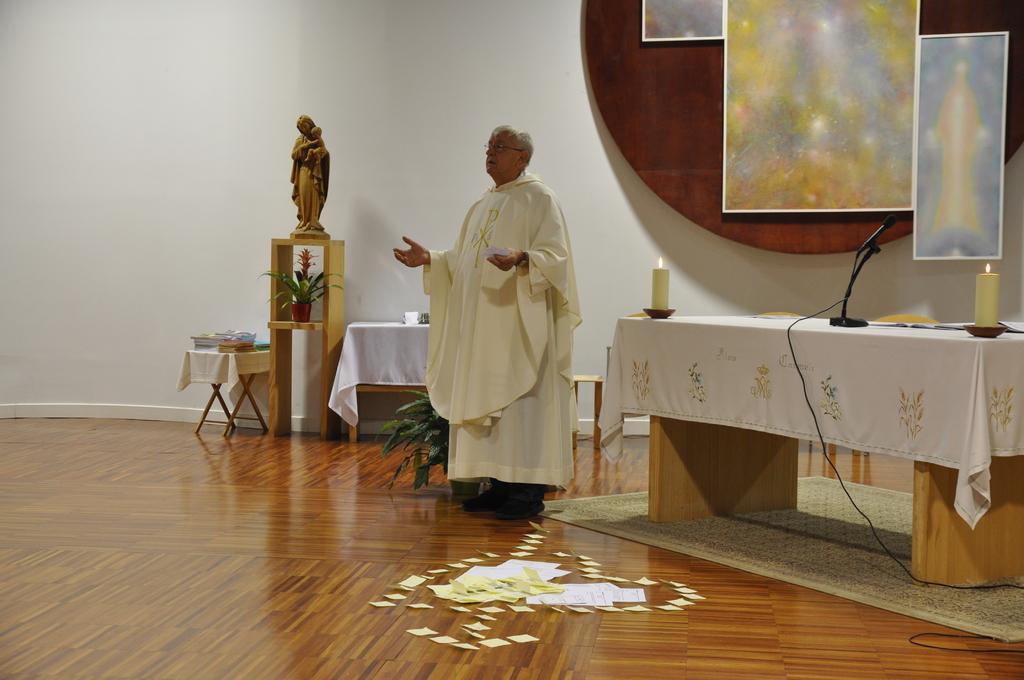Please provide a concise description of this image. In this image we can see a man is standing, there are white papers on the floor, beside there is a table and a white cloth on it, there are candles, there is a microphone, there is a wire, there is a flower pot, there is a sculpture on a wooden table, beside there is a stand and some objects on it, there are frames on a round table, there is a wire. 